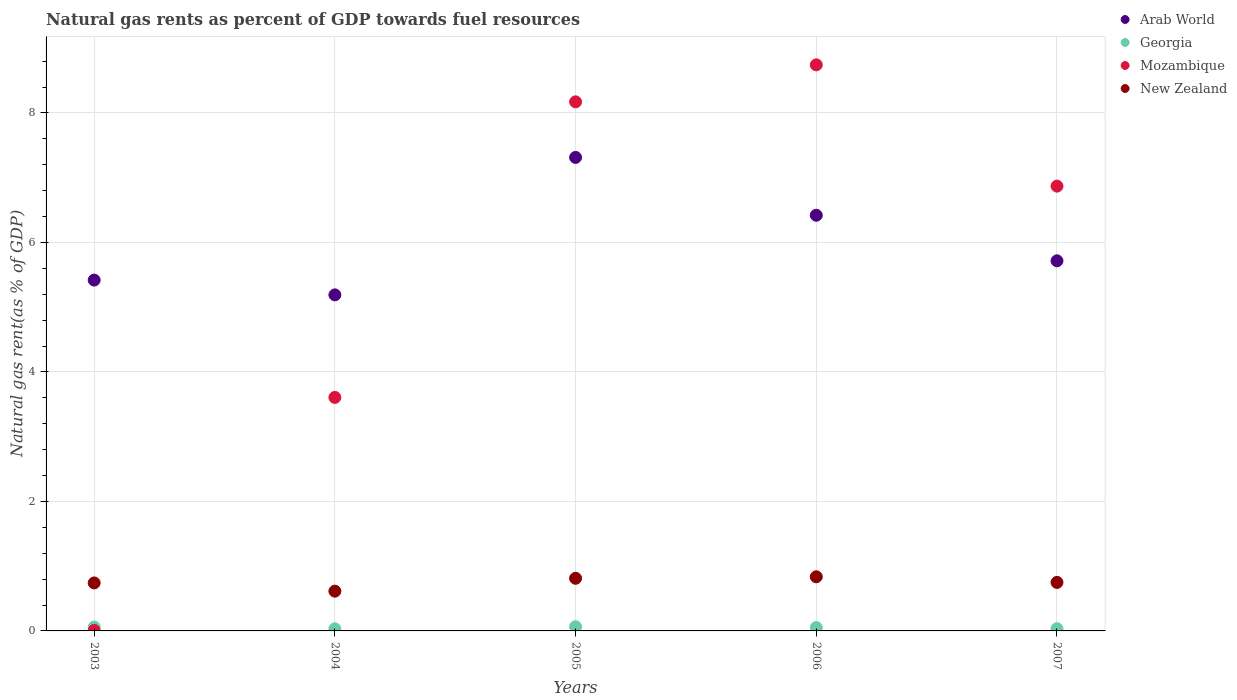How many different coloured dotlines are there?
Offer a very short reply. 4. What is the natural gas rent in Mozambique in 2005?
Keep it short and to the point. 8.17. Across all years, what is the maximum natural gas rent in Arab World?
Provide a succinct answer. 7.31. Across all years, what is the minimum natural gas rent in Georgia?
Give a very brief answer. 0.03. In which year was the natural gas rent in Arab World maximum?
Give a very brief answer. 2005. What is the total natural gas rent in Georgia in the graph?
Offer a terse response. 0.24. What is the difference between the natural gas rent in Mozambique in 2003 and that in 2006?
Offer a very short reply. -8.73. What is the difference between the natural gas rent in New Zealand in 2004 and the natural gas rent in Georgia in 2007?
Offer a very short reply. 0.58. What is the average natural gas rent in Georgia per year?
Provide a succinct answer. 0.05. In the year 2004, what is the difference between the natural gas rent in Arab World and natural gas rent in Mozambique?
Offer a terse response. 1.58. What is the ratio of the natural gas rent in Georgia in 2004 to that in 2006?
Provide a short and direct response. 0.63. What is the difference between the highest and the second highest natural gas rent in Arab World?
Offer a terse response. 0.89. What is the difference between the highest and the lowest natural gas rent in Mozambique?
Offer a very short reply. 8.73. In how many years, is the natural gas rent in Mozambique greater than the average natural gas rent in Mozambique taken over all years?
Your response must be concise. 3. Is the natural gas rent in Georgia strictly greater than the natural gas rent in Mozambique over the years?
Give a very brief answer. No. What is the difference between two consecutive major ticks on the Y-axis?
Offer a very short reply. 2. Are the values on the major ticks of Y-axis written in scientific E-notation?
Provide a succinct answer. No. Does the graph contain any zero values?
Your answer should be very brief. No. Does the graph contain grids?
Keep it short and to the point. Yes. How many legend labels are there?
Offer a terse response. 4. How are the legend labels stacked?
Make the answer very short. Vertical. What is the title of the graph?
Keep it short and to the point. Natural gas rents as percent of GDP towards fuel resources. What is the label or title of the X-axis?
Your answer should be very brief. Years. What is the label or title of the Y-axis?
Your response must be concise. Natural gas rent(as % of GDP). What is the Natural gas rent(as % of GDP) in Arab World in 2003?
Your answer should be very brief. 5.42. What is the Natural gas rent(as % of GDP) in Georgia in 2003?
Keep it short and to the point. 0.06. What is the Natural gas rent(as % of GDP) in Mozambique in 2003?
Give a very brief answer. 0.01. What is the Natural gas rent(as % of GDP) in New Zealand in 2003?
Offer a very short reply. 0.74. What is the Natural gas rent(as % of GDP) of Arab World in 2004?
Provide a short and direct response. 5.19. What is the Natural gas rent(as % of GDP) of Georgia in 2004?
Your response must be concise. 0.03. What is the Natural gas rent(as % of GDP) of Mozambique in 2004?
Keep it short and to the point. 3.61. What is the Natural gas rent(as % of GDP) in New Zealand in 2004?
Provide a succinct answer. 0.61. What is the Natural gas rent(as % of GDP) in Arab World in 2005?
Give a very brief answer. 7.31. What is the Natural gas rent(as % of GDP) of Georgia in 2005?
Ensure brevity in your answer.  0.07. What is the Natural gas rent(as % of GDP) in Mozambique in 2005?
Keep it short and to the point. 8.17. What is the Natural gas rent(as % of GDP) of New Zealand in 2005?
Give a very brief answer. 0.81. What is the Natural gas rent(as % of GDP) of Arab World in 2006?
Your response must be concise. 6.42. What is the Natural gas rent(as % of GDP) in Georgia in 2006?
Your response must be concise. 0.05. What is the Natural gas rent(as % of GDP) of Mozambique in 2006?
Offer a very short reply. 8.74. What is the Natural gas rent(as % of GDP) in New Zealand in 2006?
Make the answer very short. 0.84. What is the Natural gas rent(as % of GDP) of Arab World in 2007?
Your answer should be compact. 5.72. What is the Natural gas rent(as % of GDP) of Georgia in 2007?
Provide a short and direct response. 0.03. What is the Natural gas rent(as % of GDP) of Mozambique in 2007?
Keep it short and to the point. 6.87. What is the Natural gas rent(as % of GDP) in New Zealand in 2007?
Ensure brevity in your answer.  0.75. Across all years, what is the maximum Natural gas rent(as % of GDP) of Arab World?
Provide a short and direct response. 7.31. Across all years, what is the maximum Natural gas rent(as % of GDP) of Georgia?
Provide a short and direct response. 0.07. Across all years, what is the maximum Natural gas rent(as % of GDP) of Mozambique?
Ensure brevity in your answer.  8.74. Across all years, what is the maximum Natural gas rent(as % of GDP) in New Zealand?
Ensure brevity in your answer.  0.84. Across all years, what is the minimum Natural gas rent(as % of GDP) of Arab World?
Offer a very short reply. 5.19. Across all years, what is the minimum Natural gas rent(as % of GDP) in Georgia?
Your response must be concise. 0.03. Across all years, what is the minimum Natural gas rent(as % of GDP) in Mozambique?
Make the answer very short. 0.01. Across all years, what is the minimum Natural gas rent(as % of GDP) of New Zealand?
Give a very brief answer. 0.61. What is the total Natural gas rent(as % of GDP) in Arab World in the graph?
Make the answer very short. 30.06. What is the total Natural gas rent(as % of GDP) of Georgia in the graph?
Ensure brevity in your answer.  0.24. What is the total Natural gas rent(as % of GDP) of Mozambique in the graph?
Make the answer very short. 27.4. What is the total Natural gas rent(as % of GDP) of New Zealand in the graph?
Provide a short and direct response. 3.75. What is the difference between the Natural gas rent(as % of GDP) of Arab World in 2003 and that in 2004?
Your answer should be very brief. 0.23. What is the difference between the Natural gas rent(as % of GDP) of Georgia in 2003 and that in 2004?
Keep it short and to the point. 0.03. What is the difference between the Natural gas rent(as % of GDP) of Mozambique in 2003 and that in 2004?
Make the answer very short. -3.6. What is the difference between the Natural gas rent(as % of GDP) in New Zealand in 2003 and that in 2004?
Your answer should be very brief. 0.13. What is the difference between the Natural gas rent(as % of GDP) in Arab World in 2003 and that in 2005?
Ensure brevity in your answer.  -1.89. What is the difference between the Natural gas rent(as % of GDP) in Georgia in 2003 and that in 2005?
Make the answer very short. -0.01. What is the difference between the Natural gas rent(as % of GDP) of Mozambique in 2003 and that in 2005?
Ensure brevity in your answer.  -8.16. What is the difference between the Natural gas rent(as % of GDP) of New Zealand in 2003 and that in 2005?
Offer a terse response. -0.07. What is the difference between the Natural gas rent(as % of GDP) of Arab World in 2003 and that in 2006?
Your response must be concise. -1. What is the difference between the Natural gas rent(as % of GDP) in Georgia in 2003 and that in 2006?
Make the answer very short. 0.01. What is the difference between the Natural gas rent(as % of GDP) in Mozambique in 2003 and that in 2006?
Offer a terse response. -8.73. What is the difference between the Natural gas rent(as % of GDP) in New Zealand in 2003 and that in 2006?
Ensure brevity in your answer.  -0.1. What is the difference between the Natural gas rent(as % of GDP) of Arab World in 2003 and that in 2007?
Your response must be concise. -0.3. What is the difference between the Natural gas rent(as % of GDP) of Georgia in 2003 and that in 2007?
Provide a short and direct response. 0.03. What is the difference between the Natural gas rent(as % of GDP) in Mozambique in 2003 and that in 2007?
Your response must be concise. -6.86. What is the difference between the Natural gas rent(as % of GDP) in New Zealand in 2003 and that in 2007?
Your response must be concise. -0.01. What is the difference between the Natural gas rent(as % of GDP) of Arab World in 2004 and that in 2005?
Offer a terse response. -2.12. What is the difference between the Natural gas rent(as % of GDP) of Georgia in 2004 and that in 2005?
Ensure brevity in your answer.  -0.03. What is the difference between the Natural gas rent(as % of GDP) of Mozambique in 2004 and that in 2005?
Your response must be concise. -4.56. What is the difference between the Natural gas rent(as % of GDP) in New Zealand in 2004 and that in 2005?
Your answer should be very brief. -0.2. What is the difference between the Natural gas rent(as % of GDP) of Arab World in 2004 and that in 2006?
Provide a short and direct response. -1.23. What is the difference between the Natural gas rent(as % of GDP) of Georgia in 2004 and that in 2006?
Your answer should be compact. -0.02. What is the difference between the Natural gas rent(as % of GDP) in Mozambique in 2004 and that in 2006?
Ensure brevity in your answer.  -5.14. What is the difference between the Natural gas rent(as % of GDP) of New Zealand in 2004 and that in 2006?
Make the answer very short. -0.22. What is the difference between the Natural gas rent(as % of GDP) of Arab World in 2004 and that in 2007?
Your response must be concise. -0.53. What is the difference between the Natural gas rent(as % of GDP) in Georgia in 2004 and that in 2007?
Ensure brevity in your answer.  -0. What is the difference between the Natural gas rent(as % of GDP) of Mozambique in 2004 and that in 2007?
Provide a short and direct response. -3.26. What is the difference between the Natural gas rent(as % of GDP) of New Zealand in 2004 and that in 2007?
Your answer should be very brief. -0.14. What is the difference between the Natural gas rent(as % of GDP) of Arab World in 2005 and that in 2006?
Provide a succinct answer. 0.89. What is the difference between the Natural gas rent(as % of GDP) in Georgia in 2005 and that in 2006?
Ensure brevity in your answer.  0.01. What is the difference between the Natural gas rent(as % of GDP) in Mozambique in 2005 and that in 2006?
Provide a short and direct response. -0.57. What is the difference between the Natural gas rent(as % of GDP) in New Zealand in 2005 and that in 2006?
Make the answer very short. -0.02. What is the difference between the Natural gas rent(as % of GDP) in Arab World in 2005 and that in 2007?
Offer a terse response. 1.6. What is the difference between the Natural gas rent(as % of GDP) in Georgia in 2005 and that in 2007?
Your answer should be very brief. 0.03. What is the difference between the Natural gas rent(as % of GDP) in Mozambique in 2005 and that in 2007?
Offer a terse response. 1.3. What is the difference between the Natural gas rent(as % of GDP) of New Zealand in 2005 and that in 2007?
Give a very brief answer. 0.06. What is the difference between the Natural gas rent(as % of GDP) in Arab World in 2006 and that in 2007?
Keep it short and to the point. 0.7. What is the difference between the Natural gas rent(as % of GDP) of Georgia in 2006 and that in 2007?
Offer a terse response. 0.02. What is the difference between the Natural gas rent(as % of GDP) in Mozambique in 2006 and that in 2007?
Give a very brief answer. 1.87. What is the difference between the Natural gas rent(as % of GDP) of New Zealand in 2006 and that in 2007?
Give a very brief answer. 0.09. What is the difference between the Natural gas rent(as % of GDP) of Arab World in 2003 and the Natural gas rent(as % of GDP) of Georgia in 2004?
Give a very brief answer. 5.39. What is the difference between the Natural gas rent(as % of GDP) of Arab World in 2003 and the Natural gas rent(as % of GDP) of Mozambique in 2004?
Your answer should be very brief. 1.81. What is the difference between the Natural gas rent(as % of GDP) in Arab World in 2003 and the Natural gas rent(as % of GDP) in New Zealand in 2004?
Make the answer very short. 4.8. What is the difference between the Natural gas rent(as % of GDP) of Georgia in 2003 and the Natural gas rent(as % of GDP) of Mozambique in 2004?
Give a very brief answer. -3.55. What is the difference between the Natural gas rent(as % of GDP) in Georgia in 2003 and the Natural gas rent(as % of GDP) in New Zealand in 2004?
Keep it short and to the point. -0.55. What is the difference between the Natural gas rent(as % of GDP) of Mozambique in 2003 and the Natural gas rent(as % of GDP) of New Zealand in 2004?
Offer a terse response. -0.61. What is the difference between the Natural gas rent(as % of GDP) in Arab World in 2003 and the Natural gas rent(as % of GDP) in Georgia in 2005?
Provide a short and direct response. 5.35. What is the difference between the Natural gas rent(as % of GDP) in Arab World in 2003 and the Natural gas rent(as % of GDP) in Mozambique in 2005?
Your response must be concise. -2.75. What is the difference between the Natural gas rent(as % of GDP) of Arab World in 2003 and the Natural gas rent(as % of GDP) of New Zealand in 2005?
Offer a very short reply. 4.61. What is the difference between the Natural gas rent(as % of GDP) of Georgia in 2003 and the Natural gas rent(as % of GDP) of Mozambique in 2005?
Give a very brief answer. -8.11. What is the difference between the Natural gas rent(as % of GDP) in Georgia in 2003 and the Natural gas rent(as % of GDP) in New Zealand in 2005?
Offer a terse response. -0.75. What is the difference between the Natural gas rent(as % of GDP) of Mozambique in 2003 and the Natural gas rent(as % of GDP) of New Zealand in 2005?
Provide a succinct answer. -0.8. What is the difference between the Natural gas rent(as % of GDP) of Arab World in 2003 and the Natural gas rent(as % of GDP) of Georgia in 2006?
Give a very brief answer. 5.37. What is the difference between the Natural gas rent(as % of GDP) of Arab World in 2003 and the Natural gas rent(as % of GDP) of Mozambique in 2006?
Make the answer very short. -3.32. What is the difference between the Natural gas rent(as % of GDP) in Arab World in 2003 and the Natural gas rent(as % of GDP) in New Zealand in 2006?
Your response must be concise. 4.58. What is the difference between the Natural gas rent(as % of GDP) of Georgia in 2003 and the Natural gas rent(as % of GDP) of Mozambique in 2006?
Give a very brief answer. -8.68. What is the difference between the Natural gas rent(as % of GDP) of Georgia in 2003 and the Natural gas rent(as % of GDP) of New Zealand in 2006?
Provide a short and direct response. -0.78. What is the difference between the Natural gas rent(as % of GDP) of Mozambique in 2003 and the Natural gas rent(as % of GDP) of New Zealand in 2006?
Offer a very short reply. -0.83. What is the difference between the Natural gas rent(as % of GDP) of Arab World in 2003 and the Natural gas rent(as % of GDP) of Georgia in 2007?
Give a very brief answer. 5.38. What is the difference between the Natural gas rent(as % of GDP) in Arab World in 2003 and the Natural gas rent(as % of GDP) in Mozambique in 2007?
Make the answer very short. -1.45. What is the difference between the Natural gas rent(as % of GDP) of Arab World in 2003 and the Natural gas rent(as % of GDP) of New Zealand in 2007?
Provide a short and direct response. 4.67. What is the difference between the Natural gas rent(as % of GDP) in Georgia in 2003 and the Natural gas rent(as % of GDP) in Mozambique in 2007?
Provide a succinct answer. -6.81. What is the difference between the Natural gas rent(as % of GDP) of Georgia in 2003 and the Natural gas rent(as % of GDP) of New Zealand in 2007?
Your answer should be compact. -0.69. What is the difference between the Natural gas rent(as % of GDP) in Mozambique in 2003 and the Natural gas rent(as % of GDP) in New Zealand in 2007?
Give a very brief answer. -0.74. What is the difference between the Natural gas rent(as % of GDP) of Arab World in 2004 and the Natural gas rent(as % of GDP) of Georgia in 2005?
Provide a succinct answer. 5.12. What is the difference between the Natural gas rent(as % of GDP) in Arab World in 2004 and the Natural gas rent(as % of GDP) in Mozambique in 2005?
Offer a terse response. -2.98. What is the difference between the Natural gas rent(as % of GDP) of Arab World in 2004 and the Natural gas rent(as % of GDP) of New Zealand in 2005?
Give a very brief answer. 4.38. What is the difference between the Natural gas rent(as % of GDP) in Georgia in 2004 and the Natural gas rent(as % of GDP) in Mozambique in 2005?
Ensure brevity in your answer.  -8.14. What is the difference between the Natural gas rent(as % of GDP) in Georgia in 2004 and the Natural gas rent(as % of GDP) in New Zealand in 2005?
Offer a terse response. -0.78. What is the difference between the Natural gas rent(as % of GDP) in Mozambique in 2004 and the Natural gas rent(as % of GDP) in New Zealand in 2005?
Your answer should be very brief. 2.79. What is the difference between the Natural gas rent(as % of GDP) in Arab World in 2004 and the Natural gas rent(as % of GDP) in Georgia in 2006?
Offer a terse response. 5.14. What is the difference between the Natural gas rent(as % of GDP) in Arab World in 2004 and the Natural gas rent(as % of GDP) in Mozambique in 2006?
Provide a short and direct response. -3.55. What is the difference between the Natural gas rent(as % of GDP) in Arab World in 2004 and the Natural gas rent(as % of GDP) in New Zealand in 2006?
Keep it short and to the point. 4.35. What is the difference between the Natural gas rent(as % of GDP) of Georgia in 2004 and the Natural gas rent(as % of GDP) of Mozambique in 2006?
Provide a succinct answer. -8.71. What is the difference between the Natural gas rent(as % of GDP) in Georgia in 2004 and the Natural gas rent(as % of GDP) in New Zealand in 2006?
Your answer should be compact. -0.8. What is the difference between the Natural gas rent(as % of GDP) of Mozambique in 2004 and the Natural gas rent(as % of GDP) of New Zealand in 2006?
Give a very brief answer. 2.77. What is the difference between the Natural gas rent(as % of GDP) of Arab World in 2004 and the Natural gas rent(as % of GDP) of Georgia in 2007?
Your response must be concise. 5.16. What is the difference between the Natural gas rent(as % of GDP) of Arab World in 2004 and the Natural gas rent(as % of GDP) of Mozambique in 2007?
Provide a short and direct response. -1.68. What is the difference between the Natural gas rent(as % of GDP) of Arab World in 2004 and the Natural gas rent(as % of GDP) of New Zealand in 2007?
Offer a very short reply. 4.44. What is the difference between the Natural gas rent(as % of GDP) in Georgia in 2004 and the Natural gas rent(as % of GDP) in Mozambique in 2007?
Your response must be concise. -6.84. What is the difference between the Natural gas rent(as % of GDP) in Georgia in 2004 and the Natural gas rent(as % of GDP) in New Zealand in 2007?
Your answer should be very brief. -0.72. What is the difference between the Natural gas rent(as % of GDP) of Mozambique in 2004 and the Natural gas rent(as % of GDP) of New Zealand in 2007?
Offer a very short reply. 2.86. What is the difference between the Natural gas rent(as % of GDP) in Arab World in 2005 and the Natural gas rent(as % of GDP) in Georgia in 2006?
Offer a terse response. 7.26. What is the difference between the Natural gas rent(as % of GDP) of Arab World in 2005 and the Natural gas rent(as % of GDP) of Mozambique in 2006?
Provide a succinct answer. -1.43. What is the difference between the Natural gas rent(as % of GDP) of Arab World in 2005 and the Natural gas rent(as % of GDP) of New Zealand in 2006?
Offer a very short reply. 6.48. What is the difference between the Natural gas rent(as % of GDP) of Georgia in 2005 and the Natural gas rent(as % of GDP) of Mozambique in 2006?
Offer a very short reply. -8.68. What is the difference between the Natural gas rent(as % of GDP) of Georgia in 2005 and the Natural gas rent(as % of GDP) of New Zealand in 2006?
Provide a short and direct response. -0.77. What is the difference between the Natural gas rent(as % of GDP) in Mozambique in 2005 and the Natural gas rent(as % of GDP) in New Zealand in 2006?
Offer a very short reply. 7.33. What is the difference between the Natural gas rent(as % of GDP) of Arab World in 2005 and the Natural gas rent(as % of GDP) of Georgia in 2007?
Give a very brief answer. 7.28. What is the difference between the Natural gas rent(as % of GDP) of Arab World in 2005 and the Natural gas rent(as % of GDP) of Mozambique in 2007?
Provide a short and direct response. 0.44. What is the difference between the Natural gas rent(as % of GDP) in Arab World in 2005 and the Natural gas rent(as % of GDP) in New Zealand in 2007?
Provide a short and direct response. 6.56. What is the difference between the Natural gas rent(as % of GDP) in Georgia in 2005 and the Natural gas rent(as % of GDP) in Mozambique in 2007?
Provide a short and direct response. -6.8. What is the difference between the Natural gas rent(as % of GDP) of Georgia in 2005 and the Natural gas rent(as % of GDP) of New Zealand in 2007?
Keep it short and to the point. -0.68. What is the difference between the Natural gas rent(as % of GDP) in Mozambique in 2005 and the Natural gas rent(as % of GDP) in New Zealand in 2007?
Your response must be concise. 7.42. What is the difference between the Natural gas rent(as % of GDP) of Arab World in 2006 and the Natural gas rent(as % of GDP) of Georgia in 2007?
Provide a succinct answer. 6.39. What is the difference between the Natural gas rent(as % of GDP) of Arab World in 2006 and the Natural gas rent(as % of GDP) of Mozambique in 2007?
Your response must be concise. -0.45. What is the difference between the Natural gas rent(as % of GDP) of Arab World in 2006 and the Natural gas rent(as % of GDP) of New Zealand in 2007?
Give a very brief answer. 5.67. What is the difference between the Natural gas rent(as % of GDP) in Georgia in 2006 and the Natural gas rent(as % of GDP) in Mozambique in 2007?
Your answer should be very brief. -6.82. What is the difference between the Natural gas rent(as % of GDP) of Georgia in 2006 and the Natural gas rent(as % of GDP) of New Zealand in 2007?
Offer a very short reply. -0.7. What is the difference between the Natural gas rent(as % of GDP) of Mozambique in 2006 and the Natural gas rent(as % of GDP) of New Zealand in 2007?
Your answer should be compact. 7.99. What is the average Natural gas rent(as % of GDP) in Arab World per year?
Provide a succinct answer. 6.01. What is the average Natural gas rent(as % of GDP) in Georgia per year?
Your answer should be very brief. 0.05. What is the average Natural gas rent(as % of GDP) in Mozambique per year?
Your answer should be very brief. 5.48. What is the average Natural gas rent(as % of GDP) in New Zealand per year?
Your response must be concise. 0.75. In the year 2003, what is the difference between the Natural gas rent(as % of GDP) of Arab World and Natural gas rent(as % of GDP) of Georgia?
Offer a terse response. 5.36. In the year 2003, what is the difference between the Natural gas rent(as % of GDP) of Arab World and Natural gas rent(as % of GDP) of Mozambique?
Offer a terse response. 5.41. In the year 2003, what is the difference between the Natural gas rent(as % of GDP) of Arab World and Natural gas rent(as % of GDP) of New Zealand?
Give a very brief answer. 4.68. In the year 2003, what is the difference between the Natural gas rent(as % of GDP) of Georgia and Natural gas rent(as % of GDP) of Mozambique?
Make the answer very short. 0.05. In the year 2003, what is the difference between the Natural gas rent(as % of GDP) of Georgia and Natural gas rent(as % of GDP) of New Zealand?
Your answer should be compact. -0.68. In the year 2003, what is the difference between the Natural gas rent(as % of GDP) of Mozambique and Natural gas rent(as % of GDP) of New Zealand?
Make the answer very short. -0.73. In the year 2004, what is the difference between the Natural gas rent(as % of GDP) in Arab World and Natural gas rent(as % of GDP) in Georgia?
Keep it short and to the point. 5.16. In the year 2004, what is the difference between the Natural gas rent(as % of GDP) of Arab World and Natural gas rent(as % of GDP) of Mozambique?
Your answer should be very brief. 1.58. In the year 2004, what is the difference between the Natural gas rent(as % of GDP) of Arab World and Natural gas rent(as % of GDP) of New Zealand?
Your response must be concise. 4.58. In the year 2004, what is the difference between the Natural gas rent(as % of GDP) of Georgia and Natural gas rent(as % of GDP) of Mozambique?
Give a very brief answer. -3.57. In the year 2004, what is the difference between the Natural gas rent(as % of GDP) of Georgia and Natural gas rent(as % of GDP) of New Zealand?
Provide a succinct answer. -0.58. In the year 2004, what is the difference between the Natural gas rent(as % of GDP) of Mozambique and Natural gas rent(as % of GDP) of New Zealand?
Offer a terse response. 2.99. In the year 2005, what is the difference between the Natural gas rent(as % of GDP) in Arab World and Natural gas rent(as % of GDP) in Georgia?
Offer a very short reply. 7.25. In the year 2005, what is the difference between the Natural gas rent(as % of GDP) of Arab World and Natural gas rent(as % of GDP) of Mozambique?
Make the answer very short. -0.86. In the year 2005, what is the difference between the Natural gas rent(as % of GDP) of Arab World and Natural gas rent(as % of GDP) of New Zealand?
Your response must be concise. 6.5. In the year 2005, what is the difference between the Natural gas rent(as % of GDP) in Georgia and Natural gas rent(as % of GDP) in Mozambique?
Offer a terse response. -8.11. In the year 2005, what is the difference between the Natural gas rent(as % of GDP) in Georgia and Natural gas rent(as % of GDP) in New Zealand?
Offer a very short reply. -0.75. In the year 2005, what is the difference between the Natural gas rent(as % of GDP) in Mozambique and Natural gas rent(as % of GDP) in New Zealand?
Your response must be concise. 7.36. In the year 2006, what is the difference between the Natural gas rent(as % of GDP) in Arab World and Natural gas rent(as % of GDP) in Georgia?
Your answer should be compact. 6.37. In the year 2006, what is the difference between the Natural gas rent(as % of GDP) of Arab World and Natural gas rent(as % of GDP) of Mozambique?
Keep it short and to the point. -2.32. In the year 2006, what is the difference between the Natural gas rent(as % of GDP) in Arab World and Natural gas rent(as % of GDP) in New Zealand?
Your response must be concise. 5.58. In the year 2006, what is the difference between the Natural gas rent(as % of GDP) of Georgia and Natural gas rent(as % of GDP) of Mozambique?
Provide a short and direct response. -8.69. In the year 2006, what is the difference between the Natural gas rent(as % of GDP) in Georgia and Natural gas rent(as % of GDP) in New Zealand?
Provide a short and direct response. -0.78. In the year 2006, what is the difference between the Natural gas rent(as % of GDP) in Mozambique and Natural gas rent(as % of GDP) in New Zealand?
Offer a terse response. 7.91. In the year 2007, what is the difference between the Natural gas rent(as % of GDP) in Arab World and Natural gas rent(as % of GDP) in Georgia?
Ensure brevity in your answer.  5.68. In the year 2007, what is the difference between the Natural gas rent(as % of GDP) in Arab World and Natural gas rent(as % of GDP) in Mozambique?
Your answer should be very brief. -1.15. In the year 2007, what is the difference between the Natural gas rent(as % of GDP) in Arab World and Natural gas rent(as % of GDP) in New Zealand?
Keep it short and to the point. 4.97. In the year 2007, what is the difference between the Natural gas rent(as % of GDP) in Georgia and Natural gas rent(as % of GDP) in Mozambique?
Your answer should be very brief. -6.83. In the year 2007, what is the difference between the Natural gas rent(as % of GDP) of Georgia and Natural gas rent(as % of GDP) of New Zealand?
Offer a terse response. -0.72. In the year 2007, what is the difference between the Natural gas rent(as % of GDP) of Mozambique and Natural gas rent(as % of GDP) of New Zealand?
Your answer should be very brief. 6.12. What is the ratio of the Natural gas rent(as % of GDP) of Arab World in 2003 to that in 2004?
Your response must be concise. 1.04. What is the ratio of the Natural gas rent(as % of GDP) in Georgia in 2003 to that in 2004?
Your answer should be very brief. 1.82. What is the ratio of the Natural gas rent(as % of GDP) of Mozambique in 2003 to that in 2004?
Keep it short and to the point. 0. What is the ratio of the Natural gas rent(as % of GDP) in New Zealand in 2003 to that in 2004?
Your answer should be very brief. 1.21. What is the ratio of the Natural gas rent(as % of GDP) in Arab World in 2003 to that in 2005?
Your answer should be very brief. 0.74. What is the ratio of the Natural gas rent(as % of GDP) in Georgia in 2003 to that in 2005?
Offer a terse response. 0.92. What is the ratio of the Natural gas rent(as % of GDP) of Mozambique in 2003 to that in 2005?
Provide a short and direct response. 0. What is the ratio of the Natural gas rent(as % of GDP) in New Zealand in 2003 to that in 2005?
Your response must be concise. 0.91. What is the ratio of the Natural gas rent(as % of GDP) of Arab World in 2003 to that in 2006?
Give a very brief answer. 0.84. What is the ratio of the Natural gas rent(as % of GDP) in Georgia in 2003 to that in 2006?
Your answer should be compact. 1.16. What is the ratio of the Natural gas rent(as % of GDP) of Mozambique in 2003 to that in 2006?
Provide a short and direct response. 0. What is the ratio of the Natural gas rent(as % of GDP) in New Zealand in 2003 to that in 2006?
Your answer should be compact. 0.89. What is the ratio of the Natural gas rent(as % of GDP) of Arab World in 2003 to that in 2007?
Your answer should be very brief. 0.95. What is the ratio of the Natural gas rent(as % of GDP) in Georgia in 2003 to that in 2007?
Offer a very short reply. 1.74. What is the ratio of the Natural gas rent(as % of GDP) in Mozambique in 2003 to that in 2007?
Offer a very short reply. 0. What is the ratio of the Natural gas rent(as % of GDP) of New Zealand in 2003 to that in 2007?
Provide a short and direct response. 0.99. What is the ratio of the Natural gas rent(as % of GDP) in Arab World in 2004 to that in 2005?
Your answer should be compact. 0.71. What is the ratio of the Natural gas rent(as % of GDP) in Georgia in 2004 to that in 2005?
Keep it short and to the point. 0.5. What is the ratio of the Natural gas rent(as % of GDP) of Mozambique in 2004 to that in 2005?
Provide a succinct answer. 0.44. What is the ratio of the Natural gas rent(as % of GDP) in New Zealand in 2004 to that in 2005?
Provide a succinct answer. 0.76. What is the ratio of the Natural gas rent(as % of GDP) of Arab World in 2004 to that in 2006?
Give a very brief answer. 0.81. What is the ratio of the Natural gas rent(as % of GDP) in Georgia in 2004 to that in 2006?
Make the answer very short. 0.63. What is the ratio of the Natural gas rent(as % of GDP) in Mozambique in 2004 to that in 2006?
Your answer should be compact. 0.41. What is the ratio of the Natural gas rent(as % of GDP) in New Zealand in 2004 to that in 2006?
Ensure brevity in your answer.  0.73. What is the ratio of the Natural gas rent(as % of GDP) of Arab World in 2004 to that in 2007?
Your response must be concise. 0.91. What is the ratio of the Natural gas rent(as % of GDP) of Georgia in 2004 to that in 2007?
Make the answer very short. 0.96. What is the ratio of the Natural gas rent(as % of GDP) in Mozambique in 2004 to that in 2007?
Your answer should be compact. 0.53. What is the ratio of the Natural gas rent(as % of GDP) in New Zealand in 2004 to that in 2007?
Your answer should be very brief. 0.82. What is the ratio of the Natural gas rent(as % of GDP) of Arab World in 2005 to that in 2006?
Provide a succinct answer. 1.14. What is the ratio of the Natural gas rent(as % of GDP) of Georgia in 2005 to that in 2006?
Ensure brevity in your answer.  1.26. What is the ratio of the Natural gas rent(as % of GDP) in Mozambique in 2005 to that in 2006?
Provide a succinct answer. 0.93. What is the ratio of the Natural gas rent(as % of GDP) in New Zealand in 2005 to that in 2006?
Provide a succinct answer. 0.97. What is the ratio of the Natural gas rent(as % of GDP) in Arab World in 2005 to that in 2007?
Keep it short and to the point. 1.28. What is the ratio of the Natural gas rent(as % of GDP) in Georgia in 2005 to that in 2007?
Your response must be concise. 1.9. What is the ratio of the Natural gas rent(as % of GDP) in Mozambique in 2005 to that in 2007?
Offer a very short reply. 1.19. What is the ratio of the Natural gas rent(as % of GDP) of New Zealand in 2005 to that in 2007?
Offer a very short reply. 1.08. What is the ratio of the Natural gas rent(as % of GDP) of Arab World in 2006 to that in 2007?
Provide a short and direct response. 1.12. What is the ratio of the Natural gas rent(as % of GDP) of Georgia in 2006 to that in 2007?
Make the answer very short. 1.51. What is the ratio of the Natural gas rent(as % of GDP) in Mozambique in 2006 to that in 2007?
Offer a terse response. 1.27. What is the ratio of the Natural gas rent(as % of GDP) of New Zealand in 2006 to that in 2007?
Your answer should be very brief. 1.12. What is the difference between the highest and the second highest Natural gas rent(as % of GDP) in Arab World?
Your answer should be compact. 0.89. What is the difference between the highest and the second highest Natural gas rent(as % of GDP) of Georgia?
Provide a succinct answer. 0.01. What is the difference between the highest and the second highest Natural gas rent(as % of GDP) of Mozambique?
Give a very brief answer. 0.57. What is the difference between the highest and the second highest Natural gas rent(as % of GDP) in New Zealand?
Your answer should be compact. 0.02. What is the difference between the highest and the lowest Natural gas rent(as % of GDP) of Arab World?
Your response must be concise. 2.12. What is the difference between the highest and the lowest Natural gas rent(as % of GDP) in Georgia?
Your response must be concise. 0.03. What is the difference between the highest and the lowest Natural gas rent(as % of GDP) of Mozambique?
Offer a terse response. 8.73. What is the difference between the highest and the lowest Natural gas rent(as % of GDP) of New Zealand?
Offer a terse response. 0.22. 